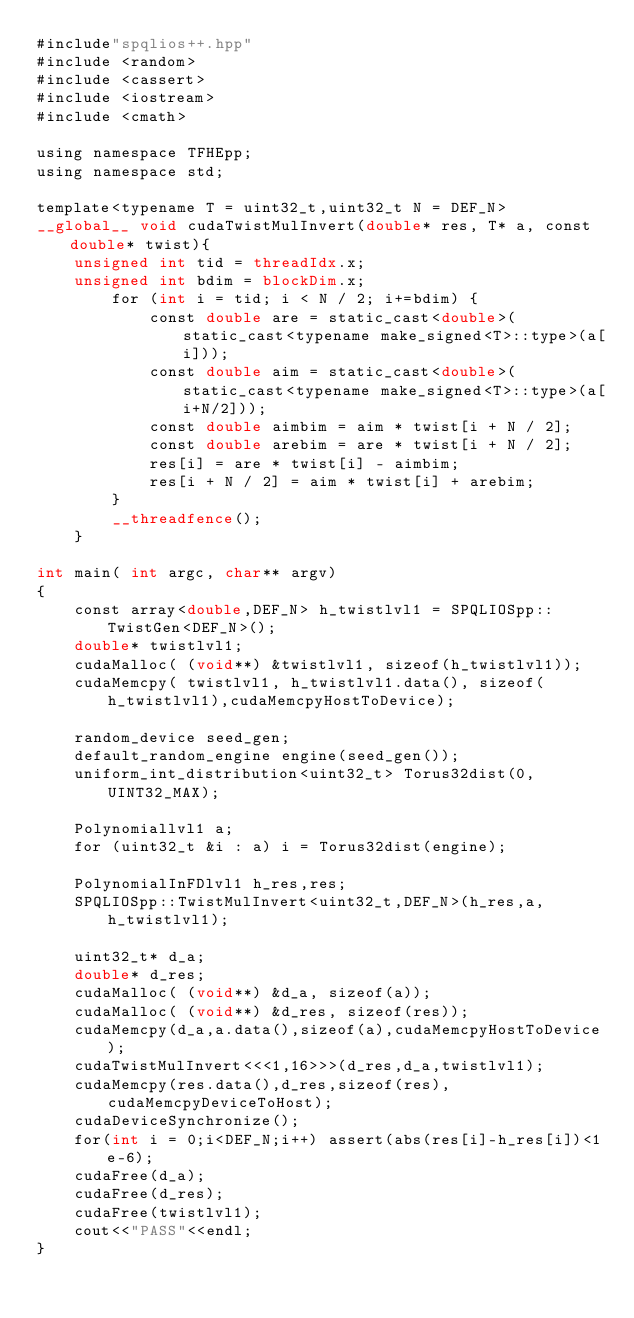Convert code to text. <code><loc_0><loc_0><loc_500><loc_500><_Cuda_>#include"spqlios++.hpp"
#include <random>
#include <cassert>
#include <iostream>
#include <cmath>

using namespace TFHEpp;
using namespace std;

template<typename T = uint32_t,uint32_t N = DEF_N>
__global__ void cudaTwistMulInvert(double* res, T* a, const double* twist){
    unsigned int tid = threadIdx.x;
    unsigned int bdim = blockDim.x;
        for (int i = tid; i < N / 2; i+=bdim) {
            const double are = static_cast<double>(static_cast<typename make_signed<T>::type>(a[i]));
            const double aim = static_cast<double>(static_cast<typename make_signed<T>::type>(a[i+N/2]));
            const double aimbim = aim * twist[i + N / 2];
            const double arebim = are * twist[i + N / 2];
            res[i] = are * twist[i] - aimbim;
            res[i + N / 2] = aim * twist[i] + arebim;
        }
        __threadfence();
    }

int main( int argc, char** argv) 
{
    const array<double,DEF_N> h_twistlvl1 = SPQLIOSpp::TwistGen<DEF_N>();
    double* twistlvl1;
    cudaMalloc( (void**) &twistlvl1, sizeof(h_twistlvl1));
    cudaMemcpy( twistlvl1, h_twistlvl1.data(), sizeof(h_twistlvl1),cudaMemcpyHostToDevice);

    random_device seed_gen;
    default_random_engine engine(seed_gen());
    uniform_int_distribution<uint32_t> Torus32dist(0, UINT32_MAX);

    Polynomiallvl1 a;
    for (uint32_t &i : a) i = Torus32dist(engine);

    PolynomialInFDlvl1 h_res,res;
    SPQLIOSpp::TwistMulInvert<uint32_t,DEF_N>(h_res,a,h_twistlvl1);

    uint32_t* d_a;
    double* d_res;
    cudaMalloc( (void**) &d_a, sizeof(a));
    cudaMalloc( (void**) &d_res, sizeof(res));
    cudaMemcpy(d_a,a.data(),sizeof(a),cudaMemcpyHostToDevice);
    cudaTwistMulInvert<<<1,16>>>(d_res,d_a,twistlvl1);
    cudaMemcpy(res.data(),d_res,sizeof(res),cudaMemcpyDeviceToHost);
    cudaDeviceSynchronize();
    for(int i = 0;i<DEF_N;i++) assert(abs(res[i]-h_res[i])<1e-6);
    cudaFree(d_a);
    cudaFree(d_res);
    cudaFree(twistlvl1);
    cout<<"PASS"<<endl;
}</code> 